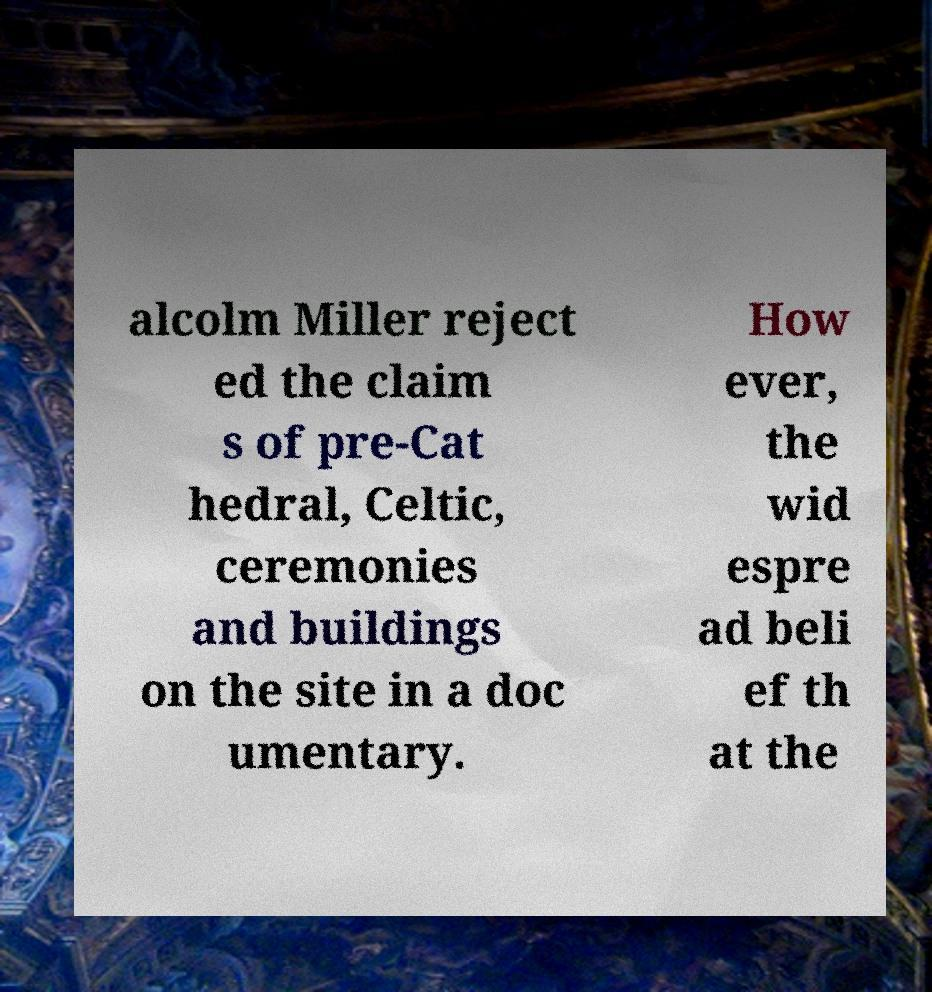Can you read and provide the text displayed in the image?This photo seems to have some interesting text. Can you extract and type it out for me? alcolm Miller reject ed the claim s of pre-Cat hedral, Celtic, ceremonies and buildings on the site in a doc umentary. How ever, the wid espre ad beli ef th at the 